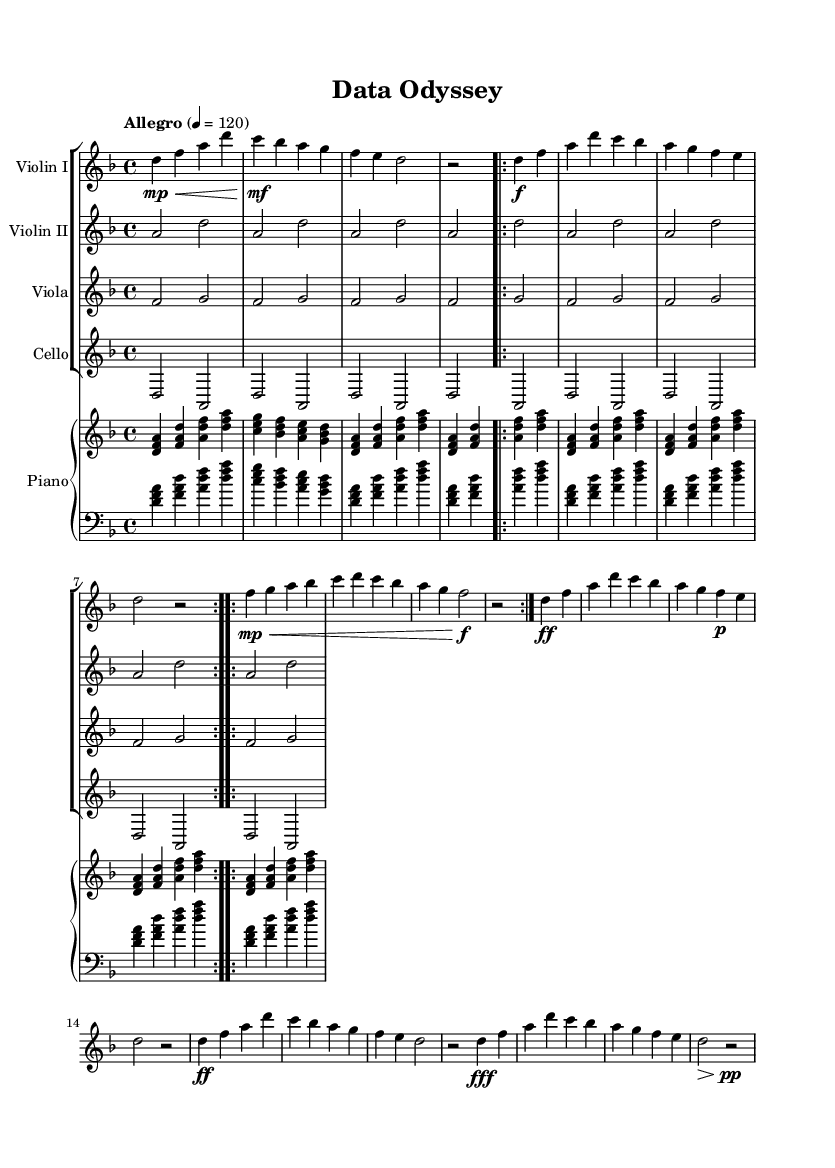What is the key signature of this music? The key signature is D minor, which has one flat (B flat).
Answer: D minor What is the time signature of this piece? The time signature is 4/4, indicating four beats per measure and a quarter note gets one beat.
Answer: 4/4 What is the tempo marking of the piece? The tempo marking indicates "Allegro" with a metronome marking of 120 beats per minute.
Answer: Allegro, 120 How many times is Theme A repeated? Theme A appears twice as indicated by the "repeat volta" marking.
Answer: Two times What dynamics are indicated at the beginning of Theme B? Theme B starts with a dynamic marking of mezzo-piano and then gradually crescendos to forte.
Answer: Mezzo-piano What is the relationship between the violins' parts? The violins play complementary roles; Violin I has the primary melody while Violin II supports harmonically.
Answer: Complementary roles What kind of movement does this piece contain, based on the structure? The piece contains a developmental structure with repeated themes and a coda, characteristic of orchestral compositions.
Answer: Developmental structure 